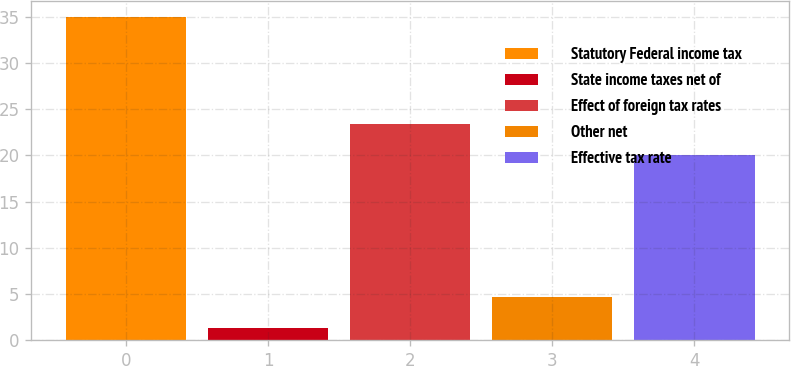<chart> <loc_0><loc_0><loc_500><loc_500><bar_chart><fcel>Statutory Federal income tax<fcel>State income taxes net of<fcel>Effect of foreign tax rates<fcel>Other net<fcel>Effective tax rate<nl><fcel>35<fcel>1.3<fcel>23.37<fcel>4.67<fcel>20<nl></chart> 